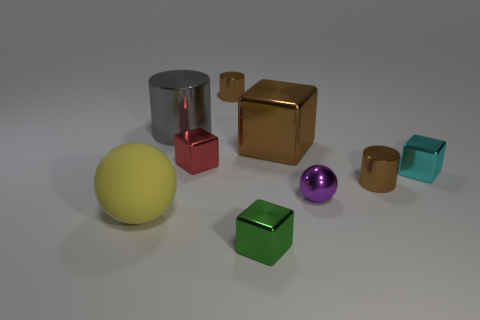Subtract all tiny metal cylinders. How many cylinders are left? 1 Subtract all yellow spheres. How many spheres are left? 1 Subtract all balls. How many objects are left? 7 Subtract 3 cylinders. How many cylinders are left? 0 Subtract 1 brown cylinders. How many objects are left? 8 Subtract all cyan cylinders. Subtract all green cubes. How many cylinders are left? 3 Subtract all cyan blocks. How many gray cylinders are left? 1 Subtract all small purple shiny balls. Subtract all gray rubber cylinders. How many objects are left? 8 Add 4 cubes. How many cubes are left? 8 Add 2 small brown metallic things. How many small brown metallic things exist? 4 